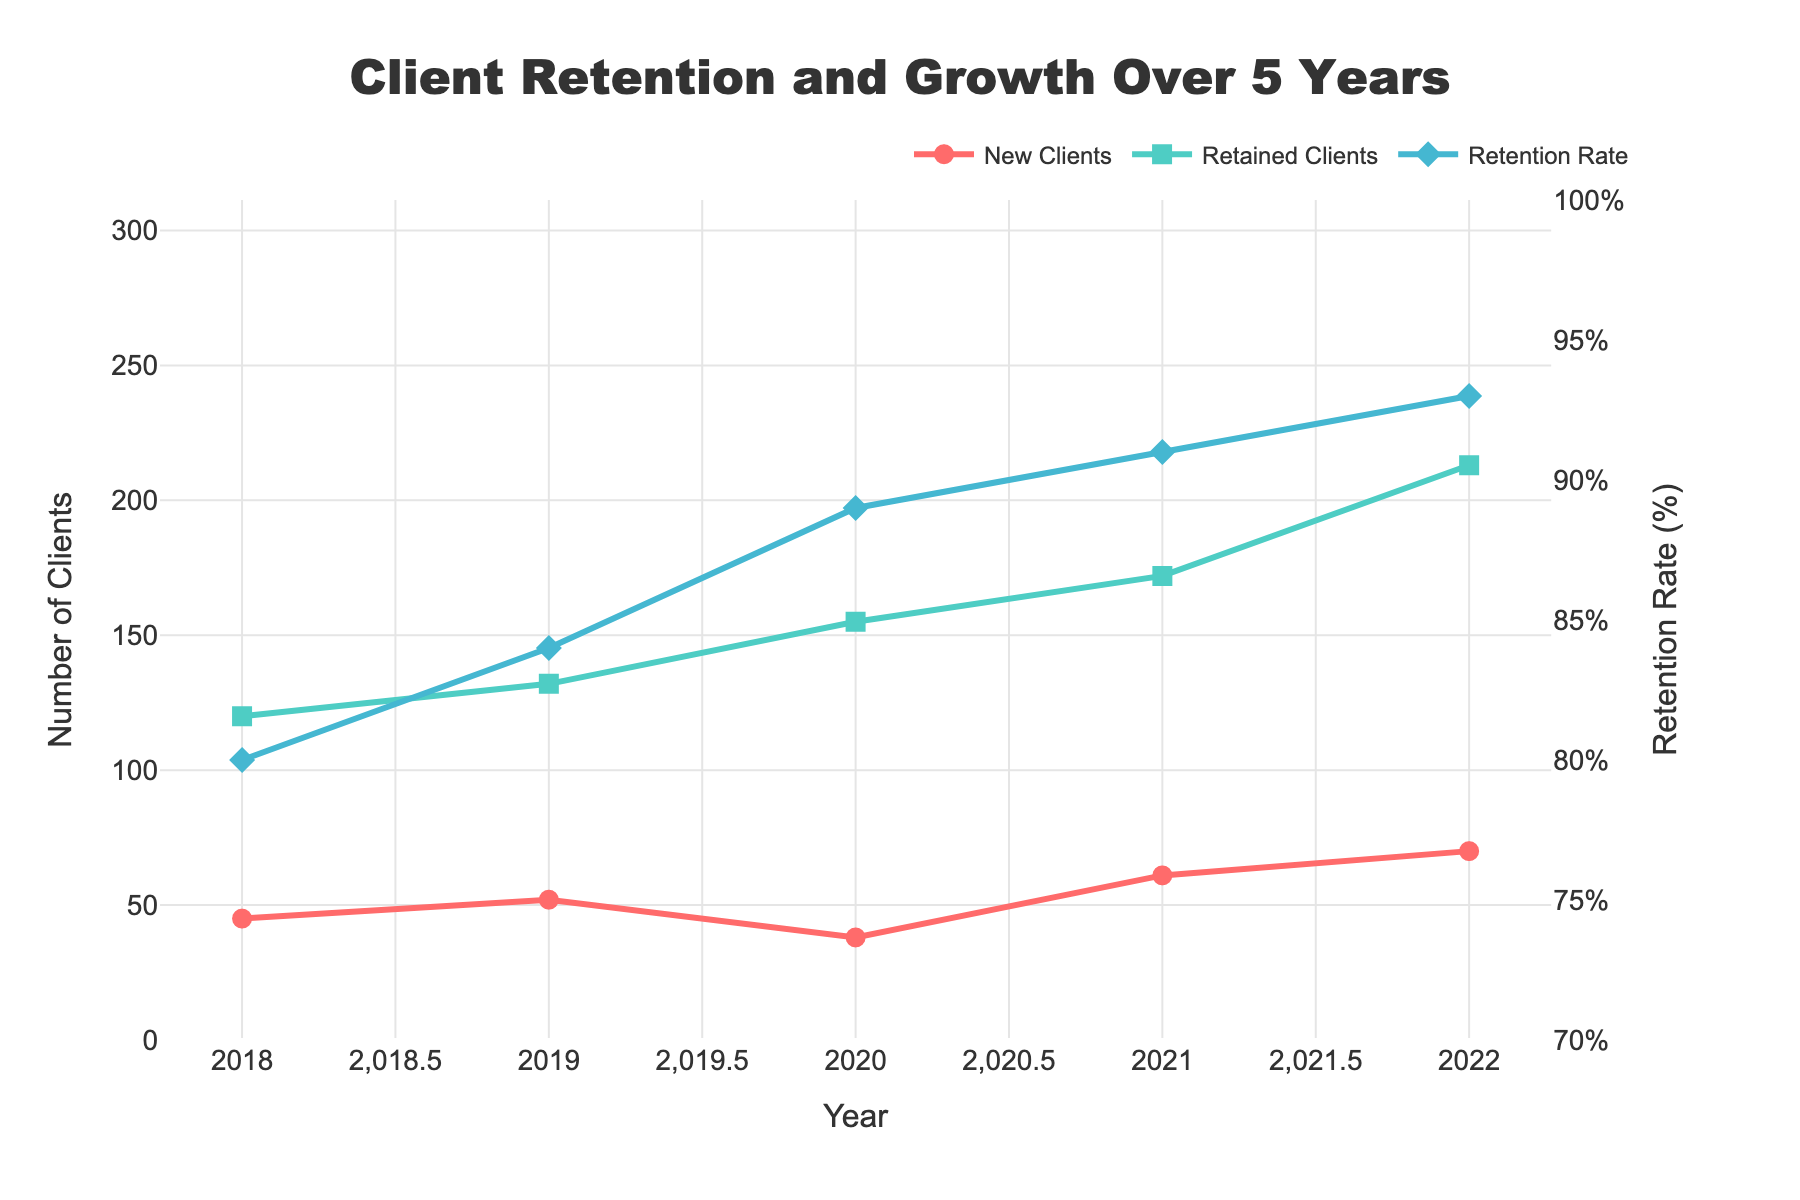What is the overall trend of the number of retained clients from 2018 to 2022? The number of retained clients increased every year, starting from 120 in 2018 and reaching 213 in 2022.
Answer: Increased Which year had the highest number of new clients? The year 2022 had the highest number of new clients, shown by the peak value in the red line representing "New Clients".
Answer: 2022 By how much did the retention rate increase from 2018 to 2022? The retention rate increased from 80% in 2018 to 93% in 2022. The difference is 93% - 80% = 13%.
Answer: 13% Compare the number of total clients in 2020 and 2021. Which year had more clients and by how many? In 2020, the total number of clients was 193, and in 2021, it was 233. So, 2021 had more clients by 233 - 193 = 40 clients.
Answer: 2021; 40 Which year shows the greatest increase in recurring revenue, and by how much? The greatest increase in recurring revenue occurred from 2021 to 2022, rising from $5.3M to $6.7M. The difference is $6.7M - $5.3M = $1.4M.
Answer: 2022; $1.4M What color represents the retention rate in the figure? The retention rate is represented by a blue line with diamond markers.
Answer: Blue Calculate the average number of retained clients over the 5-year period. The total number of retained clients over the 5 years is 120 + 132 + 155 + 172 + 213 = 792. The average is 792 / 5 = 158.4.
Answer: 158.4 Identify the year with the smallest increase in the number of retained clients compared to the previous year. The smallest increase in retained clients occurred between 2019 and 2020, where the increase was 155 - 132 = 23 clients.
Answer: 2019-2020 Which figure (New Clients or Retained Clients) shows a steeper increasing trend over the years and why? The retained clients show a steeper increasing trend as the green line representing retained clients has a consistently rising trajectory, while the red line for new clients fluctuates more and rises more gradually.
Answer: Retained Clients 